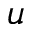Convert formula to latex. <formula><loc_0><loc_0><loc_500><loc_500>u</formula> 